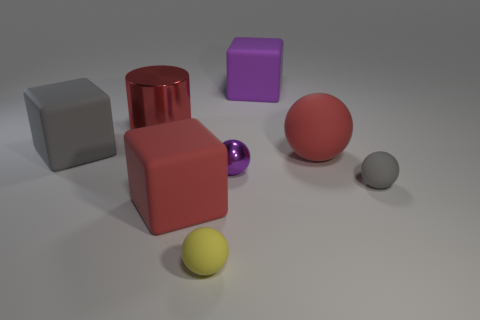Subtract all big red blocks. How many blocks are left? 2 Add 1 gray objects. How many objects exist? 9 Subtract all cylinders. How many objects are left? 7 Subtract all yellow balls. How many balls are left? 3 Subtract 3 blocks. How many blocks are left? 0 Subtract all red cubes. Subtract all cyan balls. How many cubes are left? 2 Subtract all yellow blocks. How many yellow spheres are left? 1 Subtract all big brown blocks. Subtract all yellow objects. How many objects are left? 7 Add 7 gray rubber cubes. How many gray rubber cubes are left? 8 Add 3 large red shiny things. How many large red shiny things exist? 4 